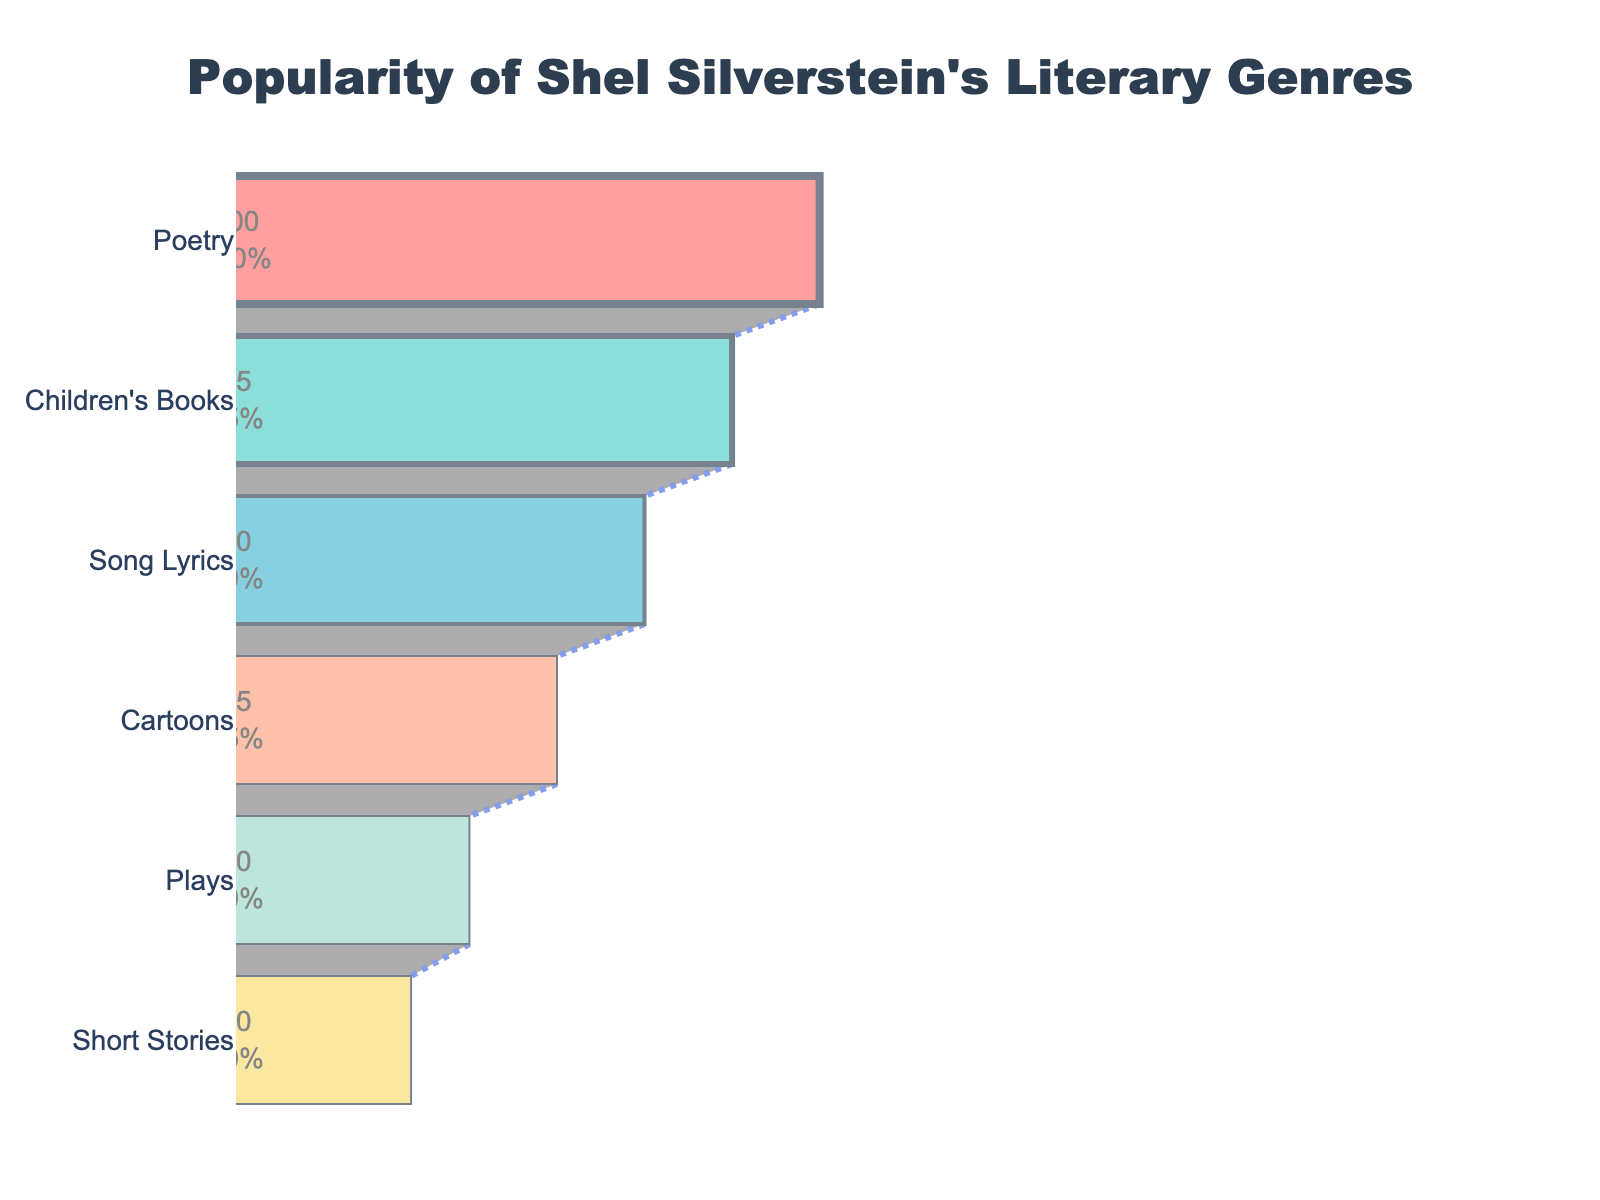what is the title of the figure? The title of a figure is usually displayed prominently at the top, providing an overview of the data being presented.
Answer: Popularity of Shel Silverstein's Literary Genres what genre is the most popular? The most popular genre will be the one with the highest value at the top of the funnel chart.
Answer: Poetry which genre has the lowest popularity? The lowest popularity genre will be at the bottom of the funnel chart, indicating the smallest value.
Answer: Short Stories how much more popular is poetry compared to plays? Look at the values for Poetry and Plays, then subtract the latter from the former. Poetry has a value of 100, and Plays have 40, so the difference is 100 - 40.
Answer: 60 what is the percentage of popularity of song lyrics compared to poetry? Compare the popularity values of Song Lyrics and Poetry. Song Lyrics has a value of 70, and Poetry has 100. The percentage is (70/100) * 100.
Answer: 70% which genre falls exactly in the middle in terms of popularity? Identify the genre that has an equal number of genres above and below it in the funnel chart. There are six genres, so the middle ones are Cartoons and Plays. Cartoons have a popularity of 55, and Plays have 40.
Answer: Cartoons what is the total popularity of children’s books, short stories, and cartoons? Sum the popularity values of these three genres: Children's Books (85), Short Stories (30), and Cartoons (55). 85 + 30 + 55 = 170.
Answer: 170 how many genres have a popularity greater than 50? Count the number of genres whose value in the chart is above 50. They are Poetry (100), Children’s Books (85), and Song Lyrics (70).
Answer: 3 what is the approximate average popularity of all the genres? Sum all genres' popularity values and divide by the number of genres. Total popularity is 100 + 85 + 70 + 55 + 40 + 30 = 380. There are 6 genres, so the average is 380/6.
Answer: 63.33 